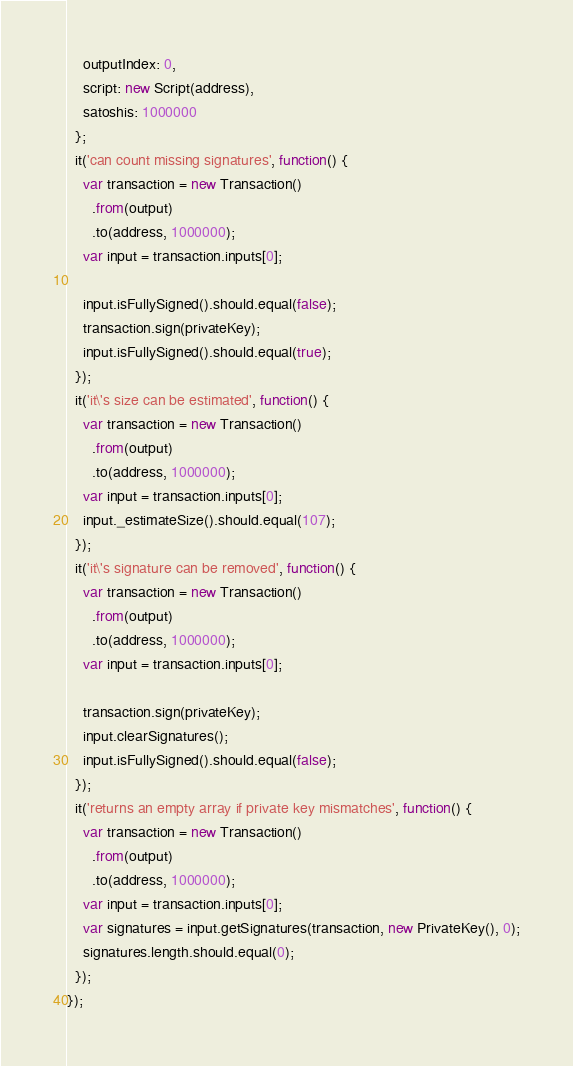<code> <loc_0><loc_0><loc_500><loc_500><_JavaScript_>    outputIndex: 0,
    script: new Script(address),
    satoshis: 1000000
  };
  it('can count missing signatures', function() {
    var transaction = new Transaction()
      .from(output)
      .to(address, 1000000);
    var input = transaction.inputs[0];

    input.isFullySigned().should.equal(false);
    transaction.sign(privateKey);
    input.isFullySigned().should.equal(true);
  });
  it('it\'s size can be estimated', function() {
    var transaction = new Transaction()
      .from(output)
      .to(address, 1000000);
    var input = transaction.inputs[0];
    input._estimateSize().should.equal(107);
  });
  it('it\'s signature can be removed', function() {
    var transaction = new Transaction()
      .from(output)
      .to(address, 1000000);
    var input = transaction.inputs[0];

    transaction.sign(privateKey);
    input.clearSignatures();
    input.isFullySigned().should.equal(false);
  });
  it('returns an empty array if private key mismatches', function() {
    var transaction = new Transaction()
      .from(output)
      .to(address, 1000000);
    var input = transaction.inputs[0];
    var signatures = input.getSignatures(transaction, new PrivateKey(), 0);
    signatures.length.should.equal(0);
  });
});
</code> 